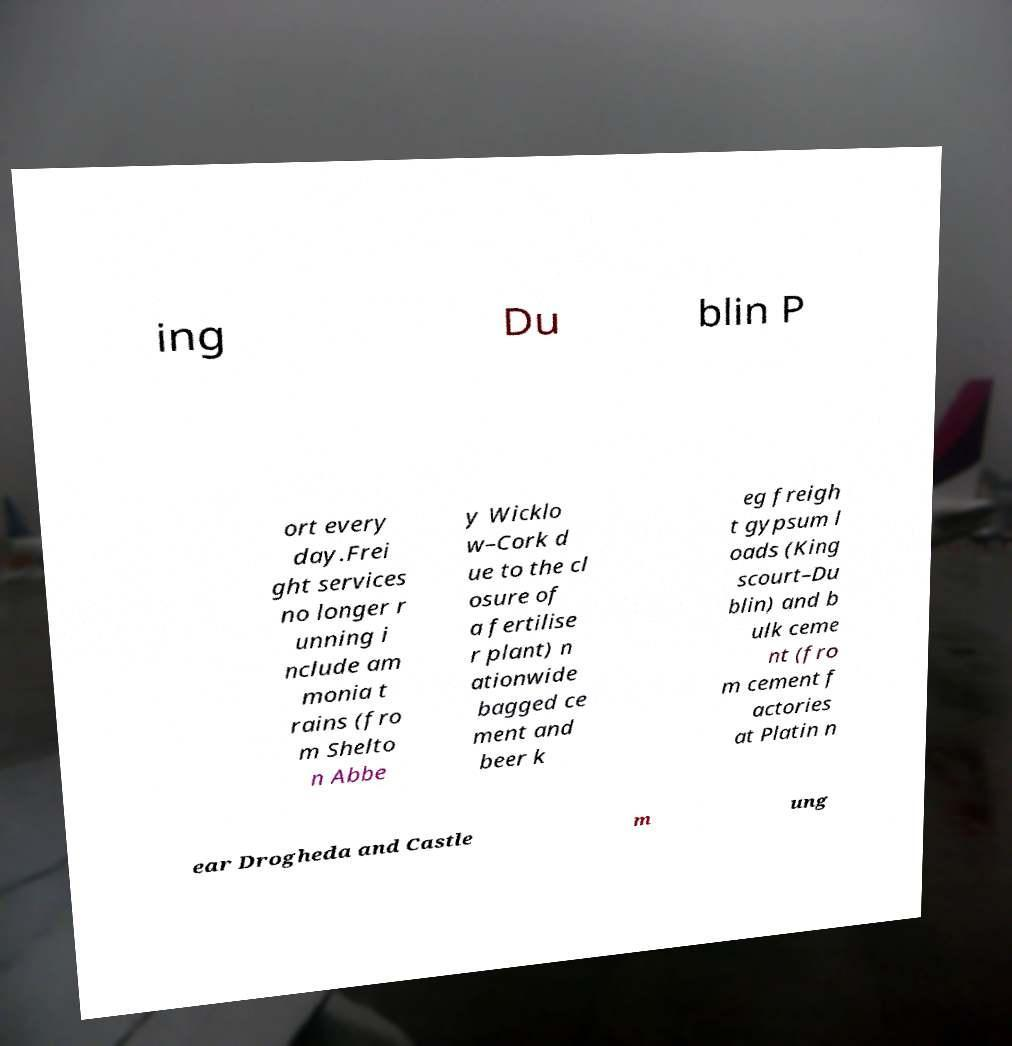Please read and relay the text visible in this image. What does it say? ing Du blin P ort every day.Frei ght services no longer r unning i nclude am monia t rains (fro m Shelto n Abbe y Wicklo w–Cork d ue to the cl osure of a fertilise r plant) n ationwide bagged ce ment and beer k eg freigh t gypsum l oads (King scourt–Du blin) and b ulk ceme nt (fro m cement f actories at Platin n ear Drogheda and Castle m ung 